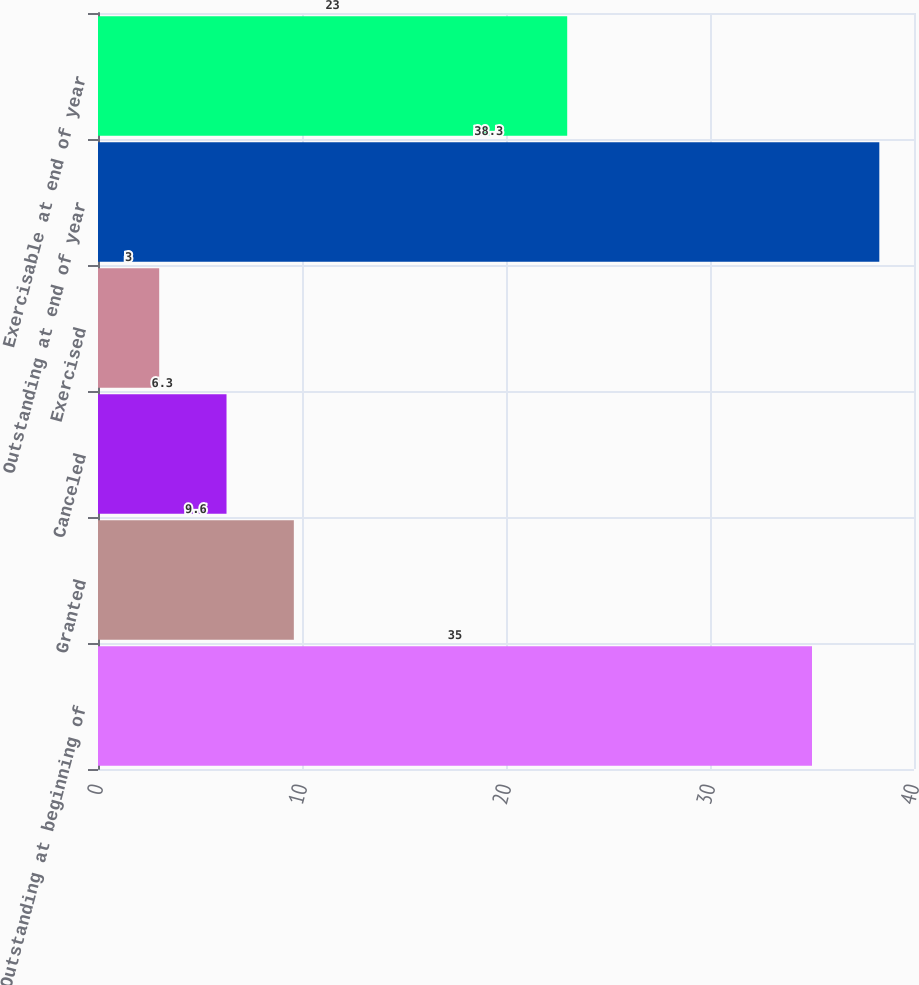Convert chart to OTSL. <chart><loc_0><loc_0><loc_500><loc_500><bar_chart><fcel>Outstanding at beginning of<fcel>Granted<fcel>Canceled<fcel>Exercised<fcel>Outstanding at end of year<fcel>Exercisable at end of year<nl><fcel>35<fcel>9.6<fcel>6.3<fcel>3<fcel>38.3<fcel>23<nl></chart> 